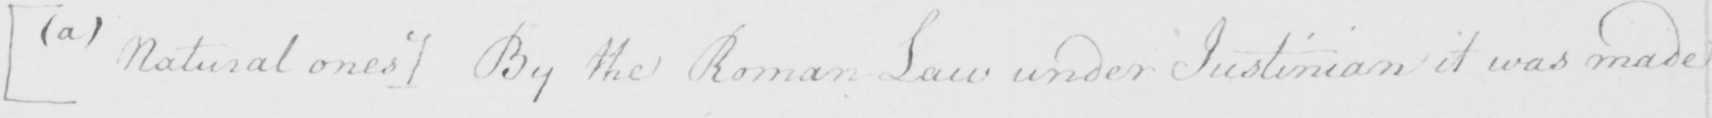Can you read and transcribe this handwriting? [  ( a )  Natural ones ]  By the Roman Law under Justinian it was made 